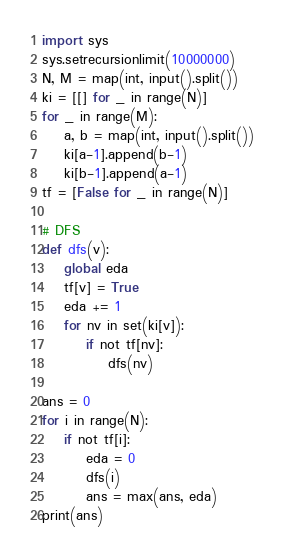Convert code to text. <code><loc_0><loc_0><loc_500><loc_500><_Python_>import sys
sys.setrecursionlimit(10000000)
N, M = map(int, input().split())
ki = [[] for _ in range(N)]
for _ in range(M):
    a, b = map(int, input().split())
    ki[a-1].append(b-1)
    ki[b-1].append(a-1)
tf = [False for _ in range(N)]

# DFS
def dfs(v):
    global eda
    tf[v] = True
    eda += 1
    for nv in set(ki[v]):
        if not tf[nv]:
            dfs(nv)

ans = 0
for i in range(N):
    if not tf[i]:
        eda = 0
        dfs(i)
        ans = max(ans, eda)
print(ans)</code> 